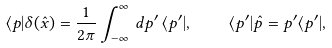<formula> <loc_0><loc_0><loc_500><loc_500>\langle { p } | \delta ( \hat { x } ) = \frac { 1 } { 2 \pi } \int _ { - \infty } ^ { \infty } \, d p { ^ { \prime } } \, \langle { p { ^ { \prime } } } | , \quad \langle { p { ^ { \prime } } } | \hat { p } = p { ^ { \prime } } \langle { p { ^ { \prime } } } | ,</formula> 